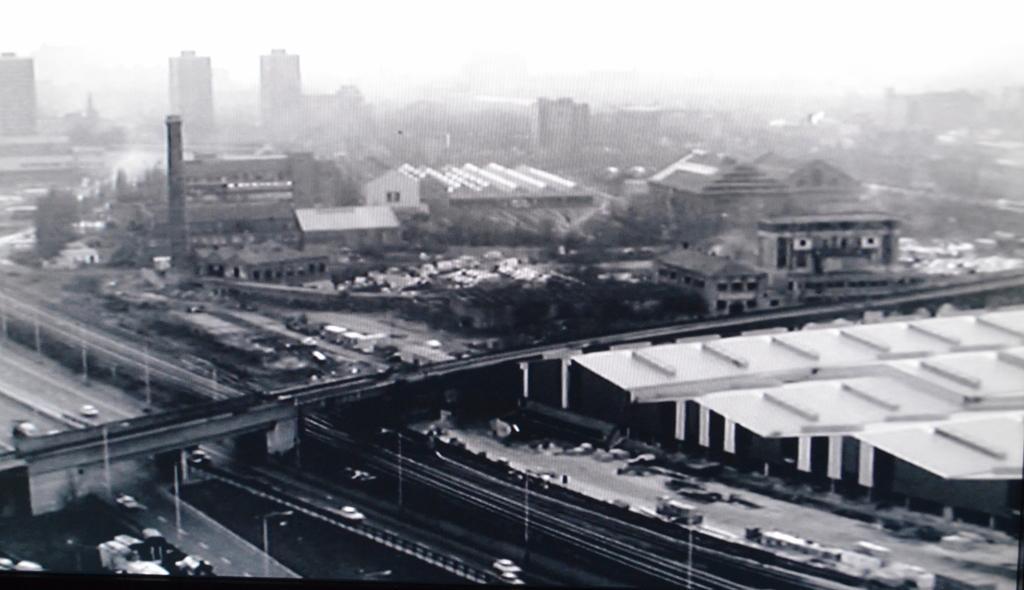Please provide a concise description of this image. This is a black and white picture of a city , where there are buildings, fly over , poles, lights, roads, vehicles, trees, and in the background there is sky. 